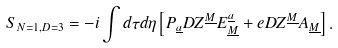<formula> <loc_0><loc_0><loc_500><loc_500>S _ { N = 1 , D = 3 } = - i \int d \tau d \eta \left [ P _ { \underline { a } } D Z ^ { \underline { M } } { E } _ { \underline { M } } ^ { \underline { a } } + e D Z ^ { \underline { M } } A _ { \underline { M } } \right ] .</formula> 